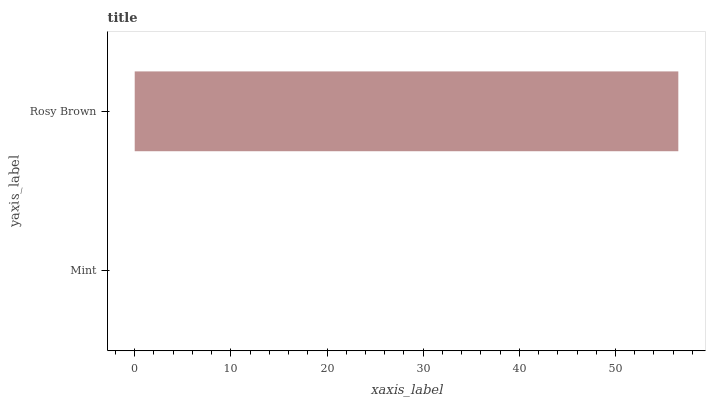Is Mint the minimum?
Answer yes or no. Yes. Is Rosy Brown the maximum?
Answer yes or no. Yes. Is Rosy Brown the minimum?
Answer yes or no. No. Is Rosy Brown greater than Mint?
Answer yes or no. Yes. Is Mint less than Rosy Brown?
Answer yes or no. Yes. Is Mint greater than Rosy Brown?
Answer yes or no. No. Is Rosy Brown less than Mint?
Answer yes or no. No. Is Rosy Brown the high median?
Answer yes or no. Yes. Is Mint the low median?
Answer yes or no. Yes. Is Mint the high median?
Answer yes or no. No. Is Rosy Brown the low median?
Answer yes or no. No. 